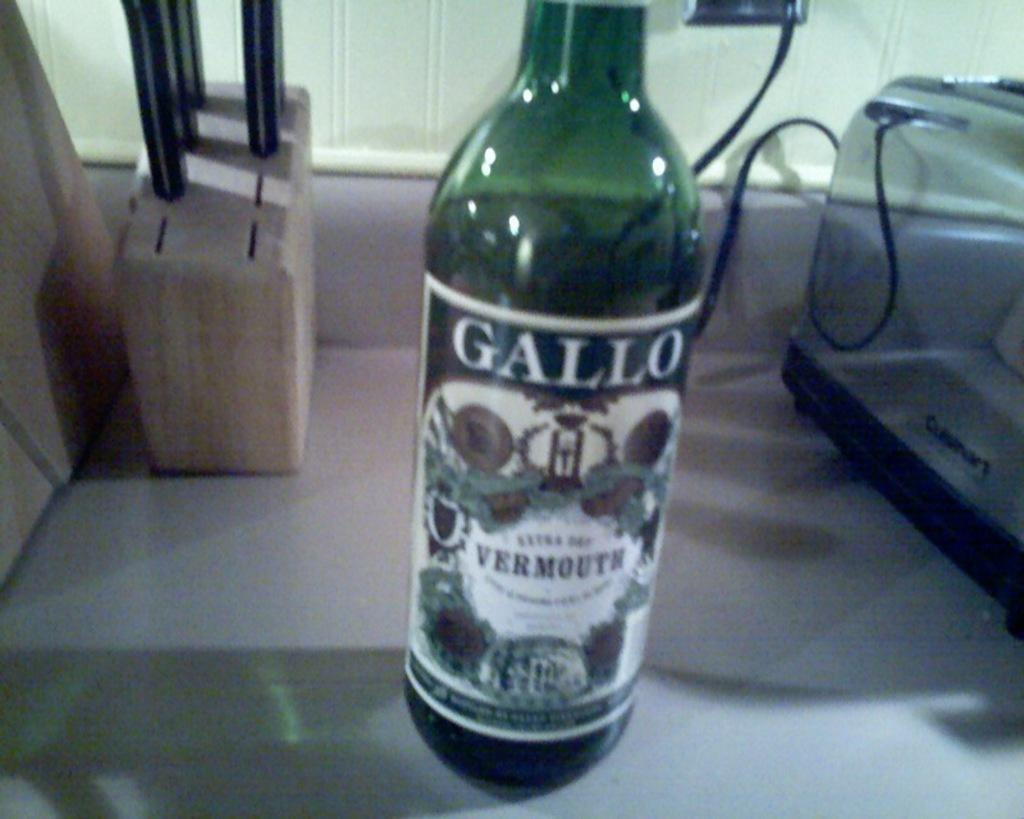Provide a one-sentence caption for the provided image. A bottle of Gallo sits between a knife block and a toaster. 